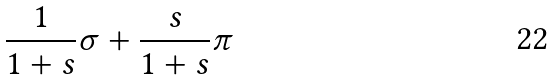<formula> <loc_0><loc_0><loc_500><loc_500>\frac { 1 } { 1 + s } \sigma + \frac { s } { 1 + s } \pi</formula> 